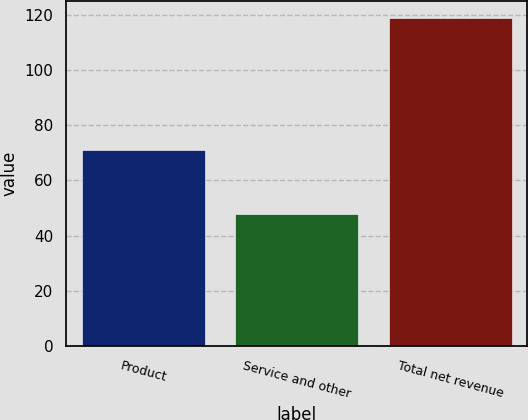Convert chart. <chart><loc_0><loc_0><loc_500><loc_500><bar_chart><fcel>Product<fcel>Service and other<fcel>Total net revenue<nl><fcel>71<fcel>48<fcel>119<nl></chart> 